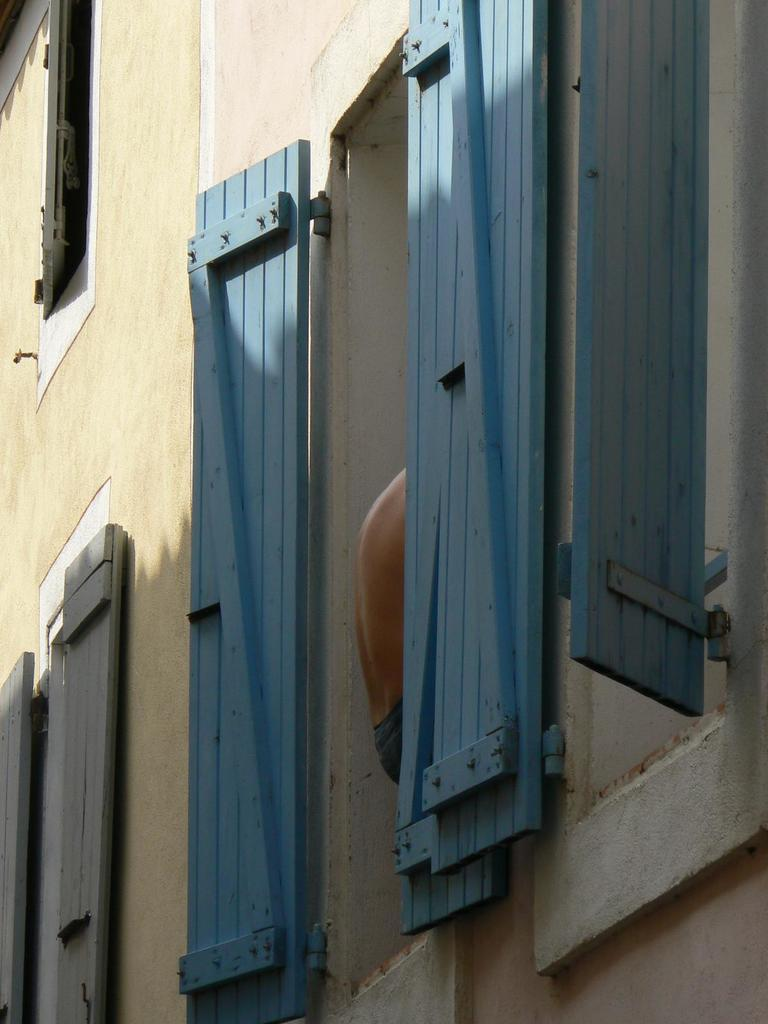What type of structure is present in the image? There is a building in the image. What feature can be seen on the building? There are windows in the building. What material is used for the objects in the image? There are wooden boards in the image. Where is the person's body located in the image? A person's body is visible in the center of the image. What type of tray is being used to increase the size of the square in the image? There is no tray or square present in the image. 